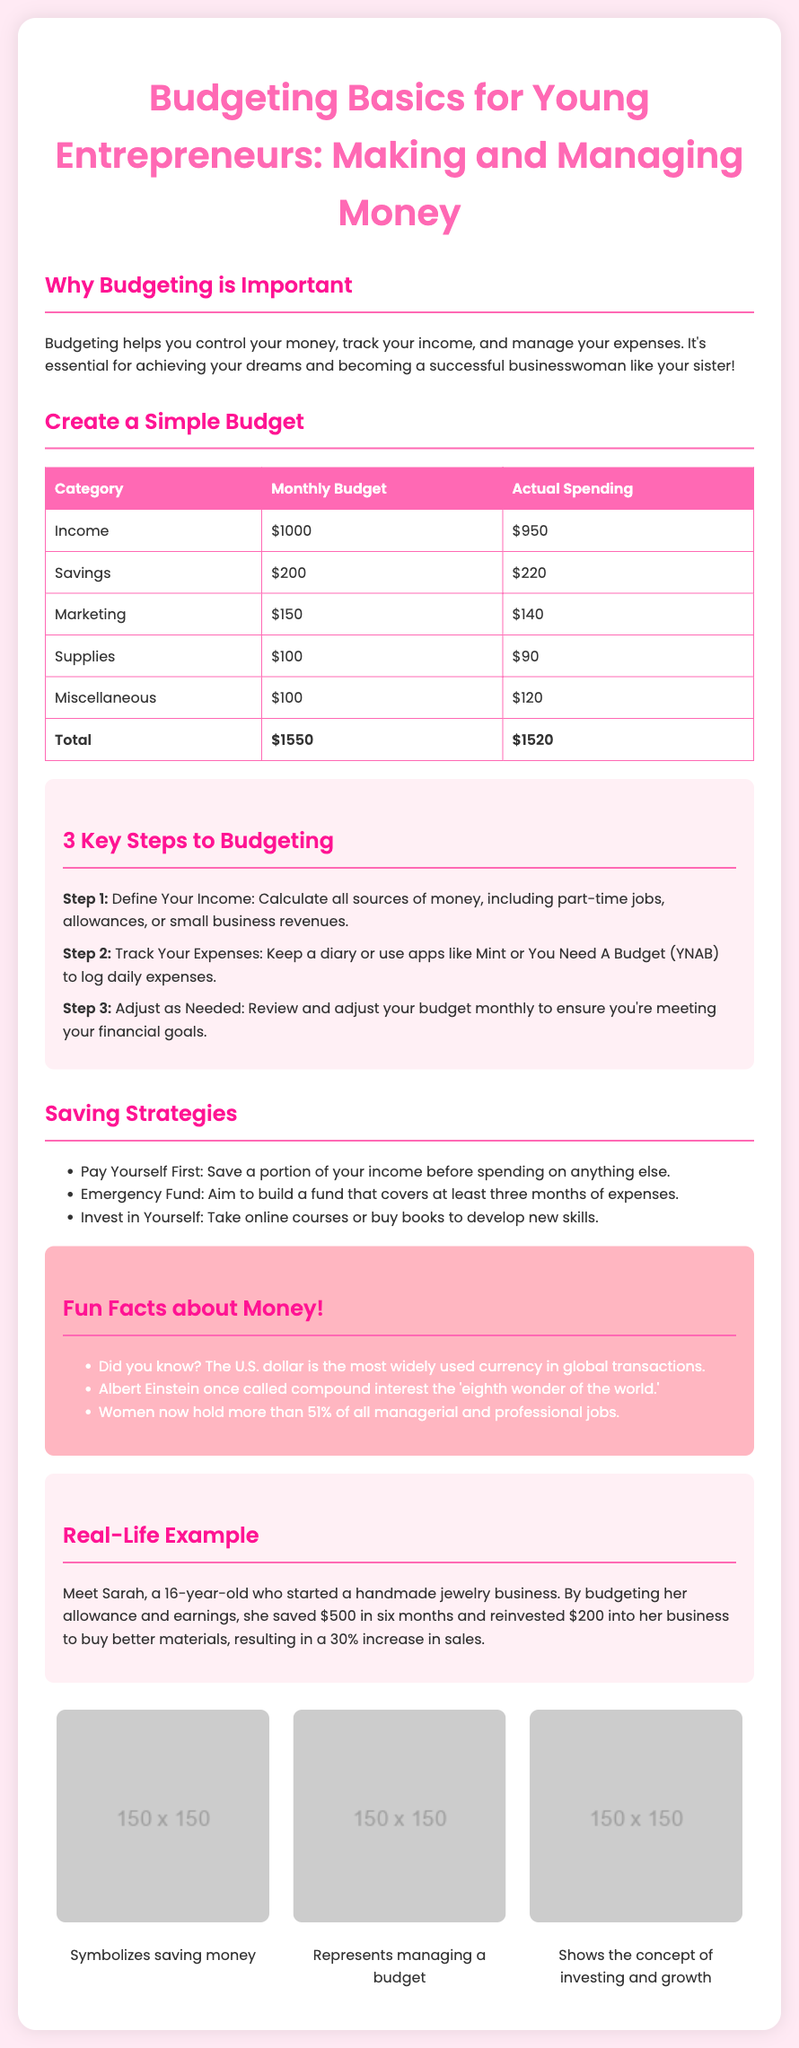What is the title of the flyer? The title is explicitly stated at the top of the document, which is "Budgeting Basics for Young Entrepreneurs: Making and Managing Money."
Answer: Budgeting Basics for Young Entrepreneurs: Making and Managing Money What is the total budget for supplies? The total budget for supplies can be found in the budget table under the supplies category, which is $100.
Answer: $100 What percentage increase did Sarah experience in her sales? The document notes that Sarah experienced a 30% increase in sales after reinvesting in her business.
Answer: 30% How many key steps to budgeting are mentioned? The document prominently lists three key steps to budgeting, which can be found in the relevant section.
Answer: 3 What is one of the saving strategies mentioned? One saving strategy highlighted in the flyer is "Pay Yourself First," which instructs to save before spending on anything else.
Answer: Pay Yourself First What is the color of the table header? The table header's color is specifically pink, as described in the styling of the document.
Answer: Pink How long did Sarah take to save $500? According to the example provided, Sarah saved $500 in six months.
Answer: Six months What is one fun fact mentioned about money? The document includes a fun fact that the U.S. dollar is the most widely used currency in global transactions.
Answer: The U.S. dollar is the most widely used currency in global transactions What type of illustration is used to symbolize saving money? The document features a "cute piggy bank illustration" to represent saving money.
Answer: Cute piggy bank illustration 